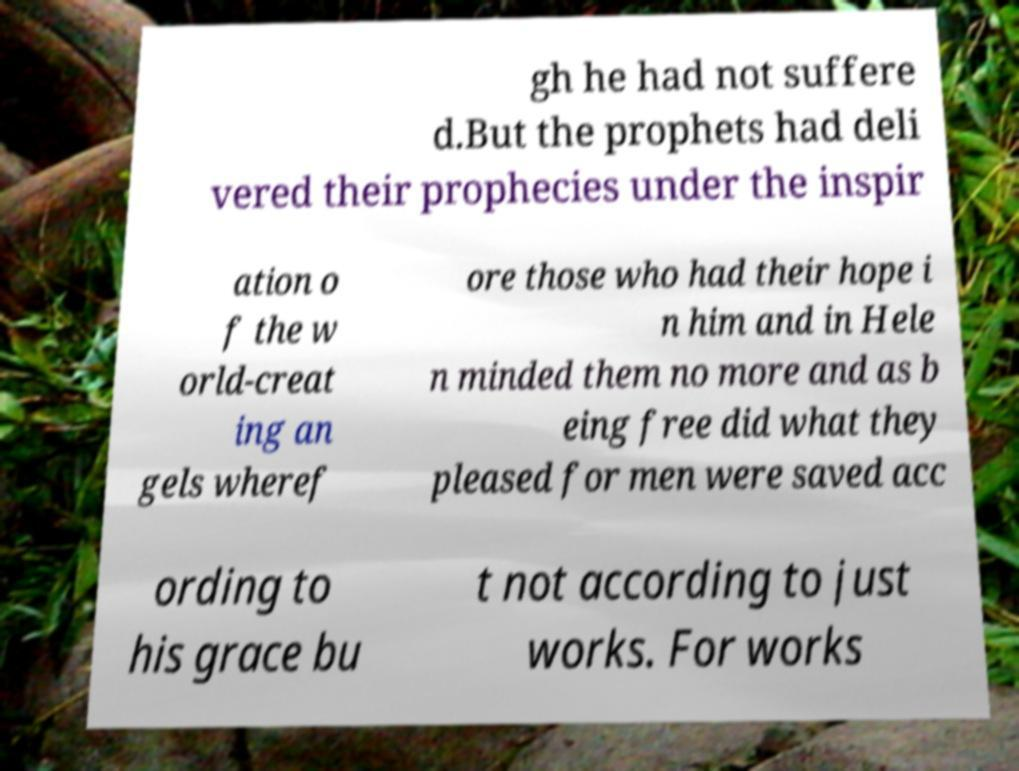What messages or text are displayed in this image? I need them in a readable, typed format. gh he had not suffere d.But the prophets had deli vered their prophecies under the inspir ation o f the w orld-creat ing an gels wheref ore those who had their hope i n him and in Hele n minded them no more and as b eing free did what they pleased for men were saved acc ording to his grace bu t not according to just works. For works 